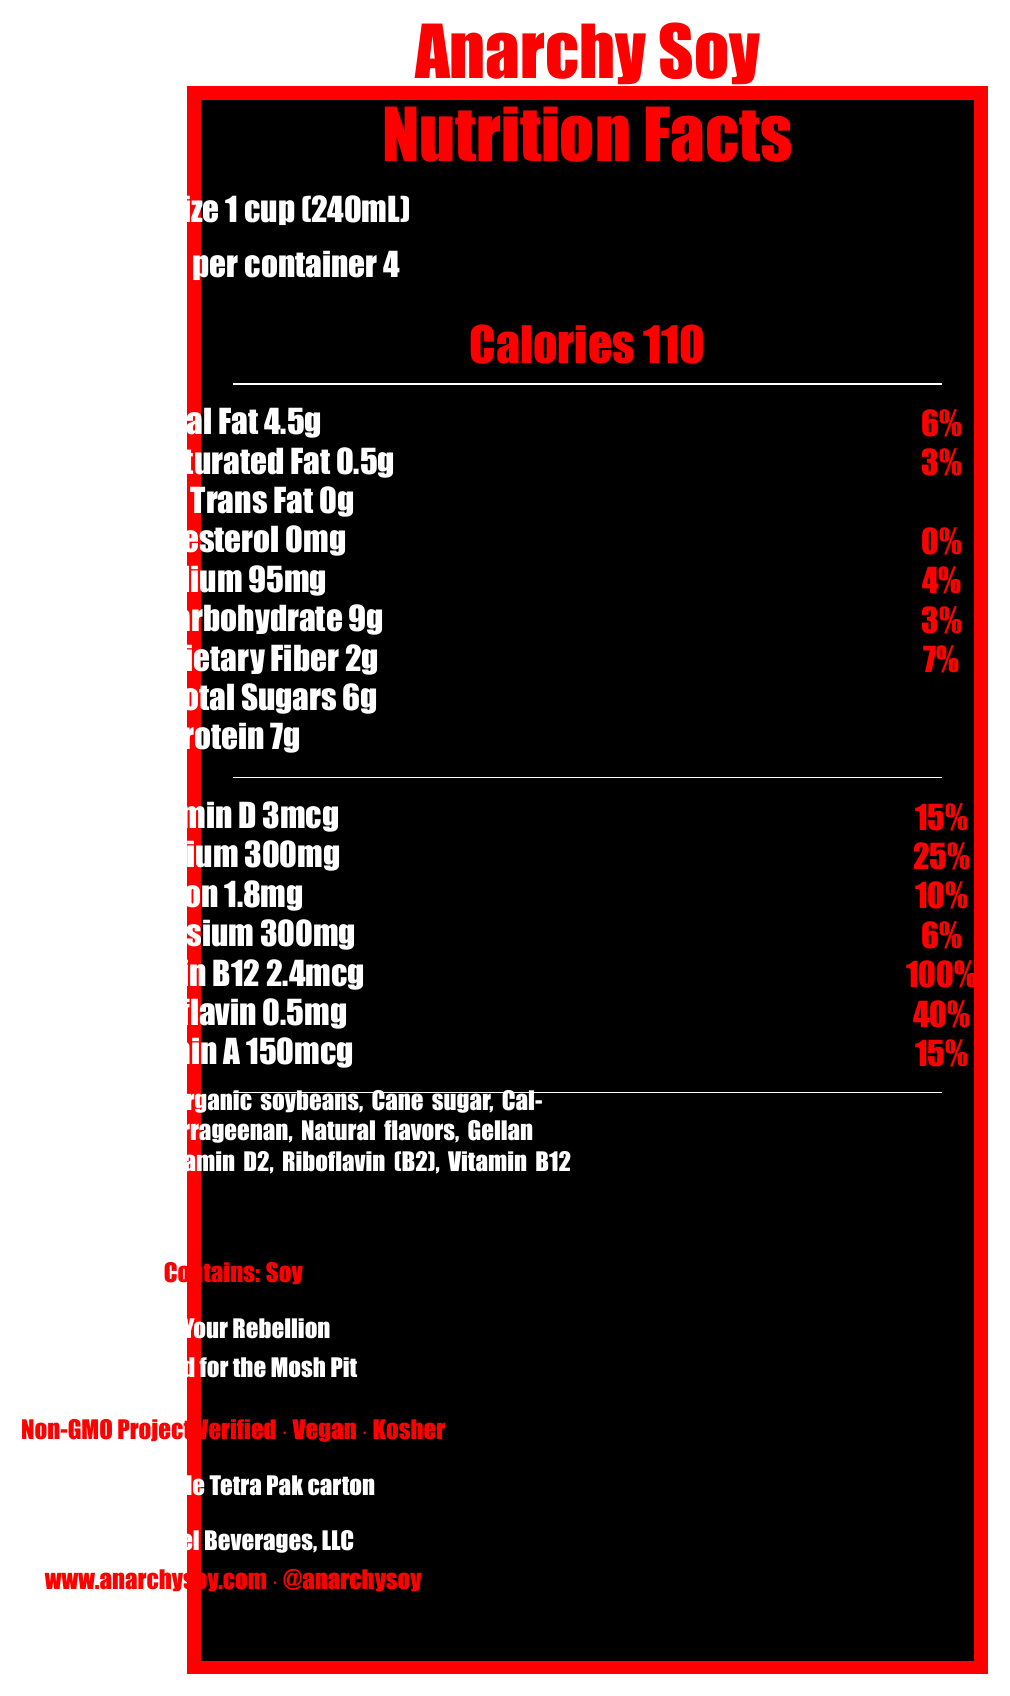What is the serving size? The serving size is listed at the top of the document.
Answer: 1 cup (240mL) How many calories are in one serving? The calories per serving is prominently displayed under the title.
Answer: 110 How much protein is in one serving of Anarchy Soy? The protein content is listed under the total sugars section.
Answer: 7g How much calcium is in one serving, and what percentage of the daily value does it represent? The calcium content and its daily value percentage are listed in the micronutrients table.
Answer: 300mg, 25% What are the first three ingredients listed? The ingredients are listed near the bottom of the document.
Answer: Filtered water, Organic soybeans, Cane sugar What vitamins are added to Anarchy Soy? These vitamins are listed in the ingredients section.
Answer: Vitamin A, Vitamin D, Riboflavin (B2), Vitamin B12 What is the manufacturer's name? The manufacturer's name is listed near the end of the document.
Answer: Riot Fuel Beverages, LLC How many servings are in one container of Anarchy Soy? The number of servings per container is listed near the top.
Answer: 4 What is the percentage of the daily value for Vitamin B12 in one serving? A. 25% B. 40% C. 100% D. 15% The Vitamin B12 daily value percentage is listed in the micronutrients table.
Answer: C. 100% What certification labels does Anarchy Soy have? A. Non-GMO Project Verified B. Vegan C. Kosher D. All of the above The document lists all three certifications: Non-GMO Project Verified, Vegan, and Kosher.
Answer: D. All of the above Is Anarchy Soy gluten-free? The document does not provide any information regarding whether the product is gluten-free.
Answer: Not enough information Does Anarchy Soy contain any allergens? The document specifies "Contains: Soy" in the allergen information section.
Answer: Yes Summarize the Nutrition Facts Label for Anarchy Soy. The summary covers the whole document, including the serving size, nutritional content, ingredients, allergen information, certifications, packaging, manufacturer, website, and punk-inspired design elements.
Answer: Anarchy Soy is a fortified soy milk with added vitamins and minerals, designed with a punk-inspired graffiti style. Each serving size is 1 cup (240mL) with 4 servings per container. It contains 110 calories per serving, with significant macronutrients and micronutrients such as Total Fat (4.5g, 6% DV), Protein (7g), Calcium (300mg, 25% DV), Vitamin B12 (2.4mcg, 100% DV), and more. The product also includes ingredients such as filtered water, organic soybeans, and cane sugar. It is soy allergen containing, non-GMO, vegan, and kosher certified. The marketing highlights include slogans like "Fuel Your Rebellion" and it is packaged in a recyclable Tetra Pak carton by Riot Fuel Beverages, LLC. The website and social media handle are provided for more information. 